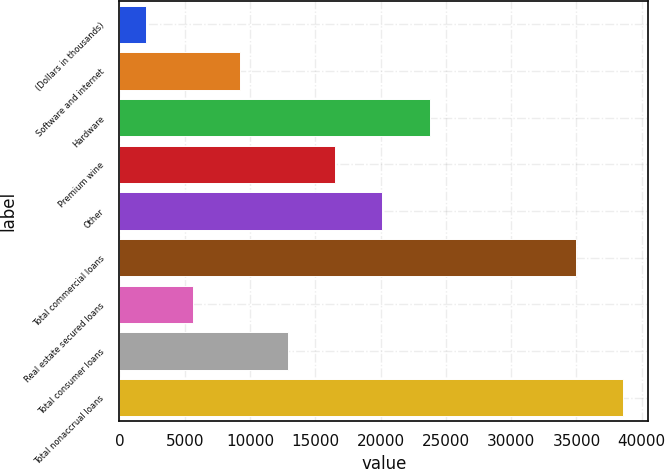Convert chart to OTSL. <chart><loc_0><loc_0><loc_500><loc_500><bar_chart><fcel>(Dollars in thousands)<fcel>Software and internet<fcel>Hardware<fcel>Premium wine<fcel>Other<fcel>Total commercial loans<fcel>Real estate secured loans<fcel>Total consumer loans<fcel>Total nonaccrual loans<nl><fcel>2012<fcel>9265.4<fcel>23772.2<fcel>16518.8<fcel>20145.5<fcel>34939<fcel>5638.7<fcel>12892.1<fcel>38565.7<nl></chart> 